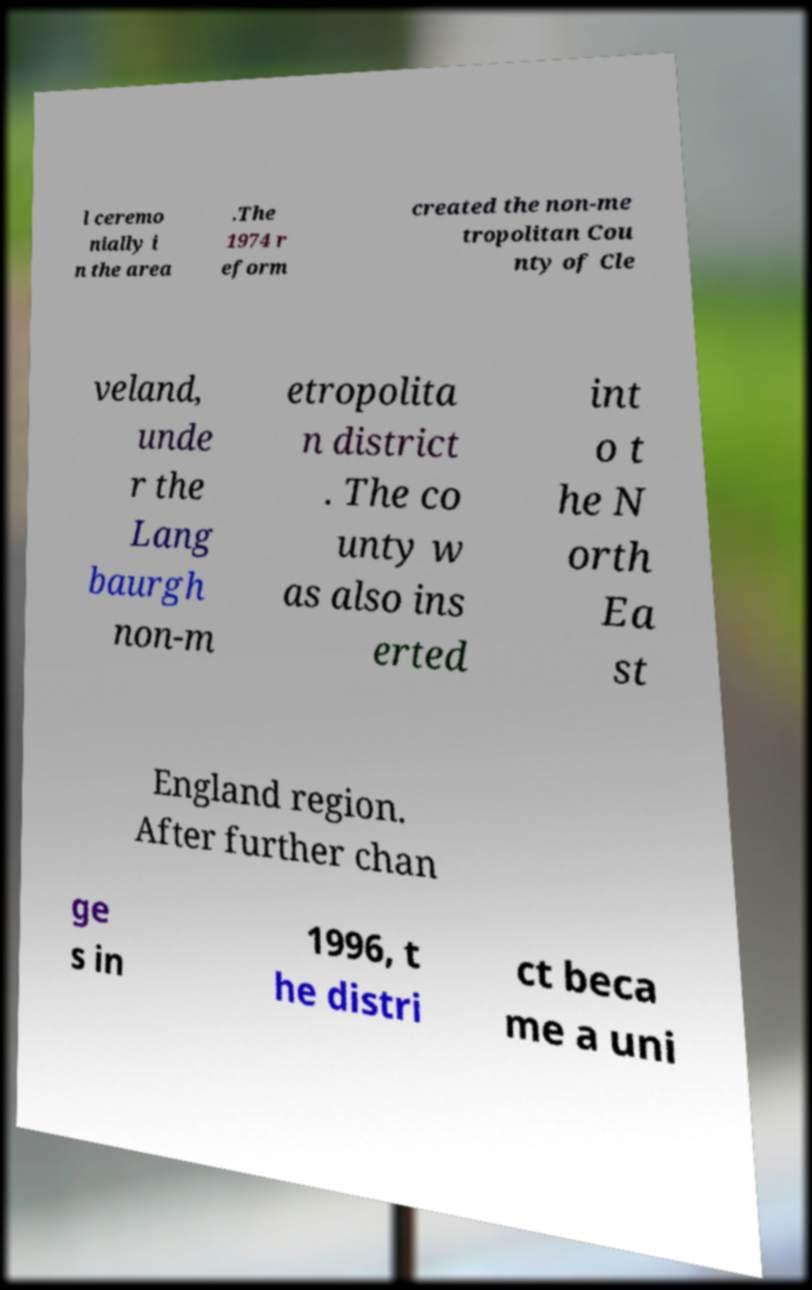Could you assist in decoding the text presented in this image and type it out clearly? l ceremo nially i n the area .The 1974 r eform created the non-me tropolitan Cou nty of Cle veland, unde r the Lang baurgh non-m etropolita n district . The co unty w as also ins erted int o t he N orth Ea st England region. After further chan ge s in 1996, t he distri ct beca me a uni 